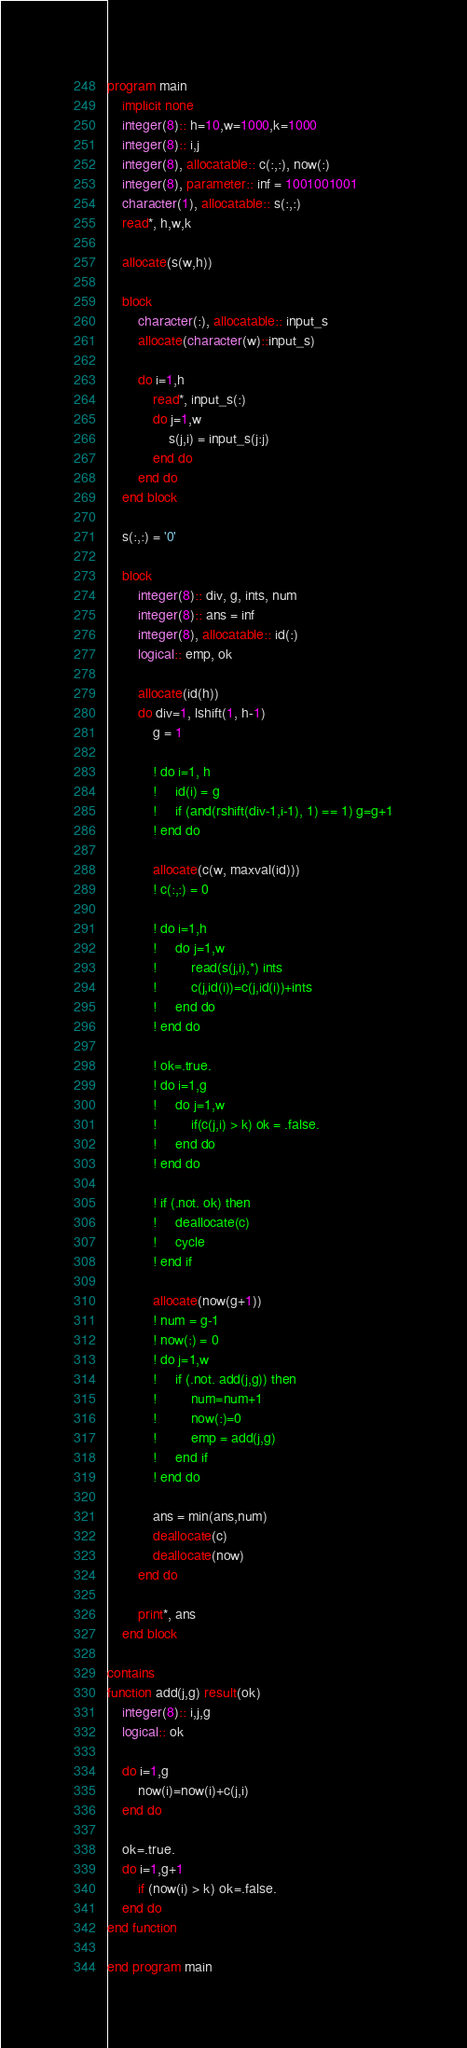<code> <loc_0><loc_0><loc_500><loc_500><_FORTRAN_>program main
    implicit none
    integer(8):: h=10,w=1000,k=1000
    integer(8):: i,j
    integer(8), allocatable:: c(:,:), now(:)
    integer(8), parameter:: inf = 1001001001
    character(1), allocatable:: s(:,:)
    read*, h,w,k
 
    allocate(s(w,h))

    block
        character(:), allocatable:: input_s
        allocate(character(w)::input_s)

        do i=1,h
            read*, input_s(:)
            do j=1,w
                s(j,i) = input_s(j:j)
            end do
        end do
    end block

    s(:,:) = '0'

    block
        integer(8):: div, g, ints, num
        integer(8):: ans = inf
        integer(8), allocatable:: id(:)
        logical:: emp, ok

        allocate(id(h))
        do div=1, lshift(1, h-1)
            g = 1

            ! do i=1, h
            !     id(i) = g
            !     if (and(rshift(div-1,i-1), 1) == 1) g=g+1
            ! end do

            allocate(c(w, maxval(id)))
            ! c(:,:) = 0

            ! do i=1,h
            !     do j=1,w
            !         read(s(j,i),*) ints
            !         c(j,id(i))=c(j,id(i))+ints
            !     end do 
            ! end do

            ! ok=.true.
            ! do i=1,g
            !     do j=1,w
            !         if(c(j,i) > k) ok = .false.
            !     end do
            ! end do

            ! if (.not. ok) then
            !     deallocate(c)
            !     cycle
            ! end if

            allocate(now(g+1))
            ! num = g-1
            ! now(:) = 0
            ! do j=1,w
            !     if (.not. add(j,g)) then
            !         num=num+1
            !         now(:)=0
            !         emp = add(j,g)
            !     end if
            ! end do 

            ans = min(ans,num)
            deallocate(c)
            deallocate(now)
        end do

        print*, ans
    end block

contains
function add(j,g) result(ok)
    integer(8):: i,j,g
    logical:: ok

    do i=1,g
        now(i)=now(i)+c(j,i)
    end do

    ok=.true.
    do i=1,g+1
        if (now(i) > k) ok=.false.
    end do
end function

end program main</code> 